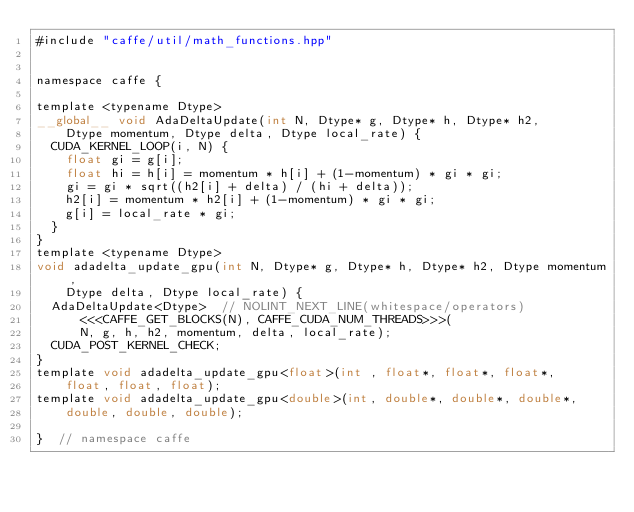<code> <loc_0><loc_0><loc_500><loc_500><_Cuda_>#include "caffe/util/math_functions.hpp"


namespace caffe {

template <typename Dtype>
__global__ void AdaDeltaUpdate(int N, Dtype* g, Dtype* h, Dtype* h2,
    Dtype momentum, Dtype delta, Dtype local_rate) {
  CUDA_KERNEL_LOOP(i, N) {
    float gi = g[i];
    float hi = h[i] = momentum * h[i] + (1-momentum) * gi * gi;
    gi = gi * sqrt((h2[i] + delta) / (hi + delta));
    h2[i] = momentum * h2[i] + (1-momentum) * gi * gi;
    g[i] = local_rate * gi;
  }
}
template <typename Dtype>
void adadelta_update_gpu(int N, Dtype* g, Dtype* h, Dtype* h2, Dtype momentum,
    Dtype delta, Dtype local_rate) {
  AdaDeltaUpdate<Dtype>  // NOLINT_NEXT_LINE(whitespace/operators)
      <<<CAFFE_GET_BLOCKS(N), CAFFE_CUDA_NUM_THREADS>>>(
      N, g, h, h2, momentum, delta, local_rate);
  CUDA_POST_KERNEL_CHECK;
}
template void adadelta_update_gpu<float>(int , float*, float*, float*,
    float, float, float);
template void adadelta_update_gpu<double>(int, double*, double*, double*,
    double, double, double);

}  // namespace caffe
</code> 